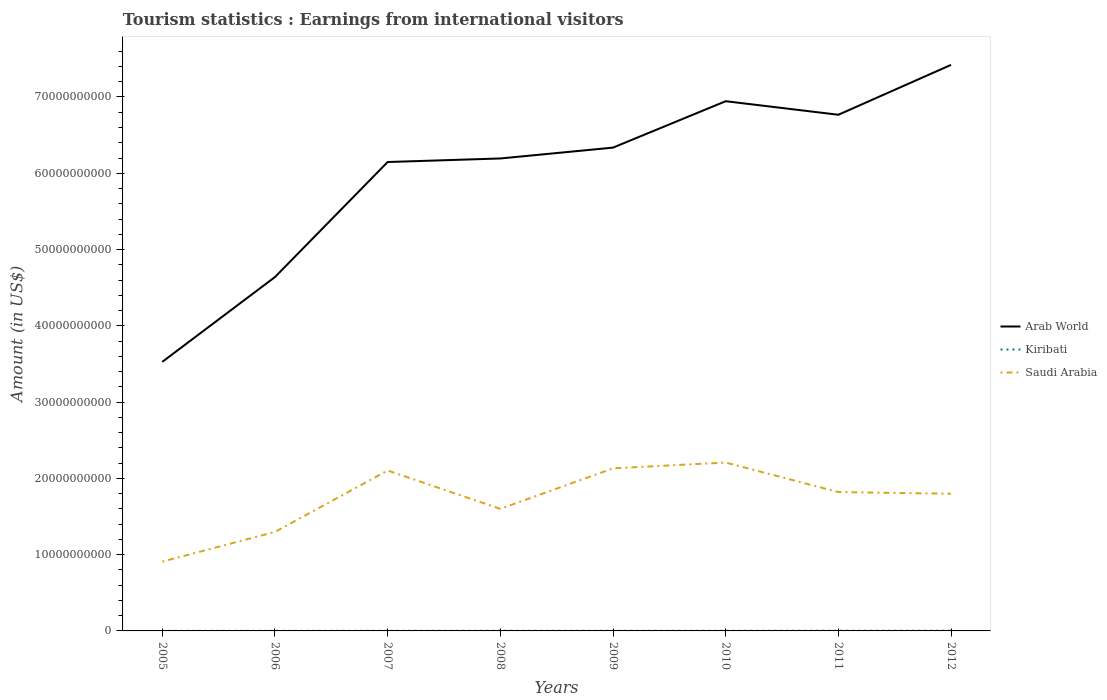Does the line corresponding to Kiribati intersect with the line corresponding to Saudi Arabia?
Provide a succinct answer. No. Across all years, what is the maximum earnings from international visitors in Kiribati?
Give a very brief answer. 9.30e+06. In which year was the earnings from international visitors in Saudi Arabia maximum?
Give a very brief answer. 2005. What is the total earnings from international visitors in Kiribati in the graph?
Make the answer very short. -9.00e+06. What is the difference between the highest and the second highest earnings from international visitors in Saudi Arabia?
Provide a succinct answer. 1.30e+1. How many lines are there?
Offer a very short reply. 3. Does the graph contain any zero values?
Your answer should be very brief. No. Does the graph contain grids?
Provide a short and direct response. No. Where does the legend appear in the graph?
Your answer should be compact. Center right. What is the title of the graph?
Ensure brevity in your answer.  Tourism statistics : Earnings from international visitors. Does "Middle East & North Africa (all income levels)" appear as one of the legend labels in the graph?
Provide a short and direct response. No. What is the label or title of the Y-axis?
Keep it short and to the point. Amount (in US$). What is the Amount (in US$) in Arab World in 2005?
Your response must be concise. 3.53e+1. What is the Amount (in US$) in Kiribati in 2005?
Provide a short and direct response. 9.30e+06. What is the Amount (in US$) in Saudi Arabia in 2005?
Keep it short and to the point. 9.09e+09. What is the Amount (in US$) of Arab World in 2006?
Your answer should be very brief. 4.64e+1. What is the Amount (in US$) in Kiribati in 2006?
Ensure brevity in your answer.  9.60e+06. What is the Amount (in US$) in Saudi Arabia in 2006?
Provide a succinct answer. 1.30e+1. What is the Amount (in US$) of Arab World in 2007?
Provide a short and direct response. 6.15e+1. What is the Amount (in US$) in Kiribati in 2007?
Your answer should be compact. 1.81e+07. What is the Amount (in US$) of Saudi Arabia in 2007?
Offer a terse response. 2.10e+1. What is the Amount (in US$) in Arab World in 2008?
Provide a succinct answer. 6.19e+1. What is the Amount (in US$) of Kiribati in 2008?
Your answer should be compact. 2.38e+07. What is the Amount (in US$) of Saudi Arabia in 2008?
Provide a short and direct response. 1.60e+1. What is the Amount (in US$) of Arab World in 2009?
Keep it short and to the point. 6.34e+1. What is the Amount (in US$) in Kiribati in 2009?
Your answer should be compact. 2.02e+07. What is the Amount (in US$) of Saudi Arabia in 2009?
Your response must be concise. 2.13e+1. What is the Amount (in US$) in Arab World in 2010?
Ensure brevity in your answer.  6.94e+1. What is the Amount (in US$) in Kiribati in 2010?
Offer a terse response. 2.26e+07. What is the Amount (in US$) in Saudi Arabia in 2010?
Ensure brevity in your answer.  2.21e+1. What is the Amount (in US$) in Arab World in 2011?
Ensure brevity in your answer.  6.77e+1. What is the Amount (in US$) in Kiribati in 2011?
Ensure brevity in your answer.  2.90e+07. What is the Amount (in US$) in Saudi Arabia in 2011?
Your answer should be compact. 1.82e+1. What is the Amount (in US$) of Arab World in 2012?
Provide a short and direct response. 7.42e+1. What is the Amount (in US$) in Kiribati in 2012?
Your answer should be very brief. 3.16e+07. What is the Amount (in US$) of Saudi Arabia in 2012?
Provide a succinct answer. 1.80e+1. Across all years, what is the maximum Amount (in US$) in Arab World?
Provide a short and direct response. 7.42e+1. Across all years, what is the maximum Amount (in US$) of Kiribati?
Give a very brief answer. 3.16e+07. Across all years, what is the maximum Amount (in US$) of Saudi Arabia?
Make the answer very short. 2.21e+1. Across all years, what is the minimum Amount (in US$) of Arab World?
Keep it short and to the point. 3.53e+1. Across all years, what is the minimum Amount (in US$) in Kiribati?
Provide a short and direct response. 9.30e+06. Across all years, what is the minimum Amount (in US$) of Saudi Arabia?
Give a very brief answer. 9.09e+09. What is the total Amount (in US$) of Arab World in the graph?
Provide a short and direct response. 4.80e+11. What is the total Amount (in US$) in Kiribati in the graph?
Make the answer very short. 1.64e+08. What is the total Amount (in US$) of Saudi Arabia in the graph?
Your response must be concise. 1.39e+11. What is the difference between the Amount (in US$) in Arab World in 2005 and that in 2006?
Offer a very short reply. -1.11e+1. What is the difference between the Amount (in US$) in Saudi Arabia in 2005 and that in 2006?
Your answer should be compact. -3.89e+09. What is the difference between the Amount (in US$) of Arab World in 2005 and that in 2007?
Your answer should be compact. -2.62e+1. What is the difference between the Amount (in US$) in Kiribati in 2005 and that in 2007?
Make the answer very short. -8.80e+06. What is the difference between the Amount (in US$) of Saudi Arabia in 2005 and that in 2007?
Your answer should be very brief. -1.19e+1. What is the difference between the Amount (in US$) of Arab World in 2005 and that in 2008?
Offer a very short reply. -2.67e+1. What is the difference between the Amount (in US$) of Kiribati in 2005 and that in 2008?
Keep it short and to the point. -1.45e+07. What is the difference between the Amount (in US$) in Saudi Arabia in 2005 and that in 2008?
Offer a very short reply. -6.92e+09. What is the difference between the Amount (in US$) in Arab World in 2005 and that in 2009?
Your answer should be compact. -2.81e+1. What is the difference between the Amount (in US$) in Kiribati in 2005 and that in 2009?
Offer a terse response. -1.09e+07. What is the difference between the Amount (in US$) of Saudi Arabia in 2005 and that in 2009?
Provide a succinct answer. -1.22e+1. What is the difference between the Amount (in US$) in Arab World in 2005 and that in 2010?
Give a very brief answer. -3.42e+1. What is the difference between the Amount (in US$) of Kiribati in 2005 and that in 2010?
Provide a succinct answer. -1.33e+07. What is the difference between the Amount (in US$) of Saudi Arabia in 2005 and that in 2010?
Your response must be concise. -1.30e+1. What is the difference between the Amount (in US$) in Arab World in 2005 and that in 2011?
Your answer should be compact. -3.24e+1. What is the difference between the Amount (in US$) in Kiribati in 2005 and that in 2011?
Keep it short and to the point. -1.97e+07. What is the difference between the Amount (in US$) of Saudi Arabia in 2005 and that in 2011?
Ensure brevity in your answer.  -9.12e+09. What is the difference between the Amount (in US$) in Arab World in 2005 and that in 2012?
Make the answer very short. -3.89e+1. What is the difference between the Amount (in US$) in Kiribati in 2005 and that in 2012?
Make the answer very short. -2.23e+07. What is the difference between the Amount (in US$) in Saudi Arabia in 2005 and that in 2012?
Provide a short and direct response. -8.90e+09. What is the difference between the Amount (in US$) of Arab World in 2006 and that in 2007?
Offer a terse response. -1.51e+1. What is the difference between the Amount (in US$) of Kiribati in 2006 and that in 2007?
Your answer should be very brief. -8.50e+06. What is the difference between the Amount (in US$) in Saudi Arabia in 2006 and that in 2007?
Make the answer very short. -8.05e+09. What is the difference between the Amount (in US$) of Arab World in 2006 and that in 2008?
Provide a succinct answer. -1.55e+1. What is the difference between the Amount (in US$) of Kiribati in 2006 and that in 2008?
Your answer should be very brief. -1.42e+07. What is the difference between the Amount (in US$) in Saudi Arabia in 2006 and that in 2008?
Ensure brevity in your answer.  -3.03e+09. What is the difference between the Amount (in US$) in Arab World in 2006 and that in 2009?
Keep it short and to the point. -1.70e+1. What is the difference between the Amount (in US$) of Kiribati in 2006 and that in 2009?
Give a very brief answer. -1.06e+07. What is the difference between the Amount (in US$) of Saudi Arabia in 2006 and that in 2009?
Offer a terse response. -8.33e+09. What is the difference between the Amount (in US$) in Arab World in 2006 and that in 2010?
Keep it short and to the point. -2.31e+1. What is the difference between the Amount (in US$) of Kiribati in 2006 and that in 2010?
Make the answer very short. -1.30e+07. What is the difference between the Amount (in US$) in Saudi Arabia in 2006 and that in 2010?
Provide a short and direct response. -9.10e+09. What is the difference between the Amount (in US$) in Arab World in 2006 and that in 2011?
Provide a succinct answer. -2.13e+1. What is the difference between the Amount (in US$) in Kiribati in 2006 and that in 2011?
Offer a terse response. -1.94e+07. What is the difference between the Amount (in US$) of Saudi Arabia in 2006 and that in 2011?
Give a very brief answer. -5.22e+09. What is the difference between the Amount (in US$) in Arab World in 2006 and that in 2012?
Your answer should be very brief. -2.78e+1. What is the difference between the Amount (in US$) of Kiribati in 2006 and that in 2012?
Offer a very short reply. -2.20e+07. What is the difference between the Amount (in US$) of Saudi Arabia in 2006 and that in 2012?
Provide a short and direct response. -5.01e+09. What is the difference between the Amount (in US$) of Arab World in 2007 and that in 2008?
Provide a succinct answer. -4.64e+08. What is the difference between the Amount (in US$) in Kiribati in 2007 and that in 2008?
Provide a succinct answer. -5.70e+06. What is the difference between the Amount (in US$) of Saudi Arabia in 2007 and that in 2008?
Keep it short and to the point. 5.03e+09. What is the difference between the Amount (in US$) in Arab World in 2007 and that in 2009?
Your response must be concise. -1.89e+09. What is the difference between the Amount (in US$) of Kiribati in 2007 and that in 2009?
Offer a very short reply. -2.10e+06. What is the difference between the Amount (in US$) in Saudi Arabia in 2007 and that in 2009?
Your answer should be compact. -2.81e+08. What is the difference between the Amount (in US$) of Arab World in 2007 and that in 2010?
Make the answer very short. -7.97e+09. What is the difference between the Amount (in US$) in Kiribati in 2007 and that in 2010?
Make the answer very short. -4.50e+06. What is the difference between the Amount (in US$) in Saudi Arabia in 2007 and that in 2010?
Make the answer very short. -1.04e+09. What is the difference between the Amount (in US$) of Arab World in 2007 and that in 2011?
Ensure brevity in your answer.  -6.20e+09. What is the difference between the Amount (in US$) of Kiribati in 2007 and that in 2011?
Provide a succinct answer. -1.09e+07. What is the difference between the Amount (in US$) of Saudi Arabia in 2007 and that in 2011?
Provide a succinct answer. 2.83e+09. What is the difference between the Amount (in US$) in Arab World in 2007 and that in 2012?
Ensure brevity in your answer.  -1.27e+1. What is the difference between the Amount (in US$) in Kiribati in 2007 and that in 2012?
Ensure brevity in your answer.  -1.35e+07. What is the difference between the Amount (in US$) of Saudi Arabia in 2007 and that in 2012?
Give a very brief answer. 3.04e+09. What is the difference between the Amount (in US$) of Arab World in 2008 and that in 2009?
Offer a terse response. -1.42e+09. What is the difference between the Amount (in US$) in Kiribati in 2008 and that in 2009?
Your answer should be very brief. 3.60e+06. What is the difference between the Amount (in US$) in Saudi Arabia in 2008 and that in 2009?
Make the answer very short. -5.31e+09. What is the difference between the Amount (in US$) in Arab World in 2008 and that in 2010?
Make the answer very short. -7.51e+09. What is the difference between the Amount (in US$) of Kiribati in 2008 and that in 2010?
Provide a succinct answer. 1.20e+06. What is the difference between the Amount (in US$) in Saudi Arabia in 2008 and that in 2010?
Offer a terse response. -6.07e+09. What is the difference between the Amount (in US$) of Arab World in 2008 and that in 2011?
Give a very brief answer. -5.73e+09. What is the difference between the Amount (in US$) of Kiribati in 2008 and that in 2011?
Your answer should be very brief. -5.20e+06. What is the difference between the Amount (in US$) in Saudi Arabia in 2008 and that in 2011?
Provide a succinct answer. -2.20e+09. What is the difference between the Amount (in US$) in Arab World in 2008 and that in 2012?
Provide a short and direct response. -1.23e+1. What is the difference between the Amount (in US$) of Kiribati in 2008 and that in 2012?
Keep it short and to the point. -7.80e+06. What is the difference between the Amount (in US$) in Saudi Arabia in 2008 and that in 2012?
Ensure brevity in your answer.  -1.98e+09. What is the difference between the Amount (in US$) in Arab World in 2009 and that in 2010?
Make the answer very short. -6.08e+09. What is the difference between the Amount (in US$) in Kiribati in 2009 and that in 2010?
Give a very brief answer. -2.40e+06. What is the difference between the Amount (in US$) in Saudi Arabia in 2009 and that in 2010?
Give a very brief answer. -7.64e+08. What is the difference between the Amount (in US$) in Arab World in 2009 and that in 2011?
Keep it short and to the point. -4.31e+09. What is the difference between the Amount (in US$) of Kiribati in 2009 and that in 2011?
Provide a succinct answer. -8.80e+06. What is the difference between the Amount (in US$) of Saudi Arabia in 2009 and that in 2011?
Provide a succinct answer. 3.11e+09. What is the difference between the Amount (in US$) in Arab World in 2009 and that in 2012?
Keep it short and to the point. -1.08e+1. What is the difference between the Amount (in US$) in Kiribati in 2009 and that in 2012?
Keep it short and to the point. -1.14e+07. What is the difference between the Amount (in US$) in Saudi Arabia in 2009 and that in 2012?
Your answer should be very brief. 3.33e+09. What is the difference between the Amount (in US$) in Arab World in 2010 and that in 2011?
Keep it short and to the point. 1.77e+09. What is the difference between the Amount (in US$) of Kiribati in 2010 and that in 2011?
Your answer should be compact. -6.40e+06. What is the difference between the Amount (in US$) in Saudi Arabia in 2010 and that in 2011?
Ensure brevity in your answer.  3.87e+09. What is the difference between the Amount (in US$) of Arab World in 2010 and that in 2012?
Your answer should be compact. -4.76e+09. What is the difference between the Amount (in US$) in Kiribati in 2010 and that in 2012?
Offer a very short reply. -9.00e+06. What is the difference between the Amount (in US$) in Saudi Arabia in 2010 and that in 2012?
Keep it short and to the point. 4.09e+09. What is the difference between the Amount (in US$) in Arab World in 2011 and that in 2012?
Your answer should be very brief. -6.54e+09. What is the difference between the Amount (in US$) in Kiribati in 2011 and that in 2012?
Provide a succinct answer. -2.60e+06. What is the difference between the Amount (in US$) of Saudi Arabia in 2011 and that in 2012?
Offer a terse response. 2.16e+08. What is the difference between the Amount (in US$) in Arab World in 2005 and the Amount (in US$) in Kiribati in 2006?
Keep it short and to the point. 3.53e+1. What is the difference between the Amount (in US$) in Arab World in 2005 and the Amount (in US$) in Saudi Arabia in 2006?
Provide a succinct answer. 2.23e+1. What is the difference between the Amount (in US$) in Kiribati in 2005 and the Amount (in US$) in Saudi Arabia in 2006?
Provide a succinct answer. -1.30e+1. What is the difference between the Amount (in US$) of Arab World in 2005 and the Amount (in US$) of Kiribati in 2007?
Provide a succinct answer. 3.53e+1. What is the difference between the Amount (in US$) of Arab World in 2005 and the Amount (in US$) of Saudi Arabia in 2007?
Ensure brevity in your answer.  1.42e+1. What is the difference between the Amount (in US$) in Kiribati in 2005 and the Amount (in US$) in Saudi Arabia in 2007?
Your response must be concise. -2.10e+1. What is the difference between the Amount (in US$) of Arab World in 2005 and the Amount (in US$) of Kiribati in 2008?
Give a very brief answer. 3.53e+1. What is the difference between the Amount (in US$) in Arab World in 2005 and the Amount (in US$) in Saudi Arabia in 2008?
Give a very brief answer. 1.93e+1. What is the difference between the Amount (in US$) of Kiribati in 2005 and the Amount (in US$) of Saudi Arabia in 2008?
Your answer should be very brief. -1.60e+1. What is the difference between the Amount (in US$) of Arab World in 2005 and the Amount (in US$) of Kiribati in 2009?
Keep it short and to the point. 3.53e+1. What is the difference between the Amount (in US$) in Arab World in 2005 and the Amount (in US$) in Saudi Arabia in 2009?
Give a very brief answer. 1.40e+1. What is the difference between the Amount (in US$) of Kiribati in 2005 and the Amount (in US$) of Saudi Arabia in 2009?
Your answer should be compact. -2.13e+1. What is the difference between the Amount (in US$) of Arab World in 2005 and the Amount (in US$) of Kiribati in 2010?
Make the answer very short. 3.53e+1. What is the difference between the Amount (in US$) of Arab World in 2005 and the Amount (in US$) of Saudi Arabia in 2010?
Make the answer very short. 1.32e+1. What is the difference between the Amount (in US$) of Kiribati in 2005 and the Amount (in US$) of Saudi Arabia in 2010?
Keep it short and to the point. -2.21e+1. What is the difference between the Amount (in US$) of Arab World in 2005 and the Amount (in US$) of Kiribati in 2011?
Provide a short and direct response. 3.52e+1. What is the difference between the Amount (in US$) of Arab World in 2005 and the Amount (in US$) of Saudi Arabia in 2011?
Ensure brevity in your answer.  1.71e+1. What is the difference between the Amount (in US$) in Kiribati in 2005 and the Amount (in US$) in Saudi Arabia in 2011?
Keep it short and to the point. -1.82e+1. What is the difference between the Amount (in US$) in Arab World in 2005 and the Amount (in US$) in Kiribati in 2012?
Provide a short and direct response. 3.52e+1. What is the difference between the Amount (in US$) in Arab World in 2005 and the Amount (in US$) in Saudi Arabia in 2012?
Ensure brevity in your answer.  1.73e+1. What is the difference between the Amount (in US$) of Kiribati in 2005 and the Amount (in US$) of Saudi Arabia in 2012?
Your answer should be compact. -1.80e+1. What is the difference between the Amount (in US$) of Arab World in 2006 and the Amount (in US$) of Kiribati in 2007?
Give a very brief answer. 4.64e+1. What is the difference between the Amount (in US$) in Arab World in 2006 and the Amount (in US$) in Saudi Arabia in 2007?
Make the answer very short. 2.54e+1. What is the difference between the Amount (in US$) of Kiribati in 2006 and the Amount (in US$) of Saudi Arabia in 2007?
Ensure brevity in your answer.  -2.10e+1. What is the difference between the Amount (in US$) in Arab World in 2006 and the Amount (in US$) in Kiribati in 2008?
Provide a short and direct response. 4.64e+1. What is the difference between the Amount (in US$) of Arab World in 2006 and the Amount (in US$) of Saudi Arabia in 2008?
Ensure brevity in your answer.  3.04e+1. What is the difference between the Amount (in US$) in Kiribati in 2006 and the Amount (in US$) in Saudi Arabia in 2008?
Your answer should be very brief. -1.60e+1. What is the difference between the Amount (in US$) of Arab World in 2006 and the Amount (in US$) of Kiribati in 2009?
Your response must be concise. 4.64e+1. What is the difference between the Amount (in US$) of Arab World in 2006 and the Amount (in US$) of Saudi Arabia in 2009?
Provide a succinct answer. 2.51e+1. What is the difference between the Amount (in US$) in Kiribati in 2006 and the Amount (in US$) in Saudi Arabia in 2009?
Provide a succinct answer. -2.13e+1. What is the difference between the Amount (in US$) of Arab World in 2006 and the Amount (in US$) of Kiribati in 2010?
Offer a terse response. 4.64e+1. What is the difference between the Amount (in US$) in Arab World in 2006 and the Amount (in US$) in Saudi Arabia in 2010?
Offer a terse response. 2.43e+1. What is the difference between the Amount (in US$) of Kiribati in 2006 and the Amount (in US$) of Saudi Arabia in 2010?
Keep it short and to the point. -2.21e+1. What is the difference between the Amount (in US$) of Arab World in 2006 and the Amount (in US$) of Kiribati in 2011?
Keep it short and to the point. 4.64e+1. What is the difference between the Amount (in US$) in Arab World in 2006 and the Amount (in US$) in Saudi Arabia in 2011?
Offer a very short reply. 2.82e+1. What is the difference between the Amount (in US$) of Kiribati in 2006 and the Amount (in US$) of Saudi Arabia in 2011?
Give a very brief answer. -1.82e+1. What is the difference between the Amount (in US$) of Arab World in 2006 and the Amount (in US$) of Kiribati in 2012?
Your answer should be compact. 4.64e+1. What is the difference between the Amount (in US$) of Arab World in 2006 and the Amount (in US$) of Saudi Arabia in 2012?
Ensure brevity in your answer.  2.84e+1. What is the difference between the Amount (in US$) in Kiribati in 2006 and the Amount (in US$) in Saudi Arabia in 2012?
Ensure brevity in your answer.  -1.80e+1. What is the difference between the Amount (in US$) of Arab World in 2007 and the Amount (in US$) of Kiribati in 2008?
Make the answer very short. 6.15e+1. What is the difference between the Amount (in US$) of Arab World in 2007 and the Amount (in US$) of Saudi Arabia in 2008?
Offer a very short reply. 4.55e+1. What is the difference between the Amount (in US$) in Kiribati in 2007 and the Amount (in US$) in Saudi Arabia in 2008?
Offer a very short reply. -1.60e+1. What is the difference between the Amount (in US$) in Arab World in 2007 and the Amount (in US$) in Kiribati in 2009?
Offer a very short reply. 6.15e+1. What is the difference between the Amount (in US$) of Arab World in 2007 and the Amount (in US$) of Saudi Arabia in 2009?
Make the answer very short. 4.02e+1. What is the difference between the Amount (in US$) of Kiribati in 2007 and the Amount (in US$) of Saudi Arabia in 2009?
Offer a very short reply. -2.13e+1. What is the difference between the Amount (in US$) of Arab World in 2007 and the Amount (in US$) of Kiribati in 2010?
Ensure brevity in your answer.  6.15e+1. What is the difference between the Amount (in US$) in Arab World in 2007 and the Amount (in US$) in Saudi Arabia in 2010?
Your answer should be very brief. 3.94e+1. What is the difference between the Amount (in US$) of Kiribati in 2007 and the Amount (in US$) of Saudi Arabia in 2010?
Your answer should be compact. -2.21e+1. What is the difference between the Amount (in US$) of Arab World in 2007 and the Amount (in US$) of Kiribati in 2011?
Ensure brevity in your answer.  6.14e+1. What is the difference between the Amount (in US$) of Arab World in 2007 and the Amount (in US$) of Saudi Arabia in 2011?
Give a very brief answer. 4.33e+1. What is the difference between the Amount (in US$) in Kiribati in 2007 and the Amount (in US$) in Saudi Arabia in 2011?
Give a very brief answer. -1.82e+1. What is the difference between the Amount (in US$) in Arab World in 2007 and the Amount (in US$) in Kiribati in 2012?
Keep it short and to the point. 6.14e+1. What is the difference between the Amount (in US$) in Arab World in 2007 and the Amount (in US$) in Saudi Arabia in 2012?
Your answer should be compact. 4.35e+1. What is the difference between the Amount (in US$) in Kiribati in 2007 and the Amount (in US$) in Saudi Arabia in 2012?
Provide a succinct answer. -1.80e+1. What is the difference between the Amount (in US$) in Arab World in 2008 and the Amount (in US$) in Kiribati in 2009?
Your answer should be very brief. 6.19e+1. What is the difference between the Amount (in US$) of Arab World in 2008 and the Amount (in US$) of Saudi Arabia in 2009?
Keep it short and to the point. 4.06e+1. What is the difference between the Amount (in US$) in Kiribati in 2008 and the Amount (in US$) in Saudi Arabia in 2009?
Offer a terse response. -2.13e+1. What is the difference between the Amount (in US$) of Arab World in 2008 and the Amount (in US$) of Kiribati in 2010?
Make the answer very short. 6.19e+1. What is the difference between the Amount (in US$) in Arab World in 2008 and the Amount (in US$) in Saudi Arabia in 2010?
Your answer should be very brief. 3.99e+1. What is the difference between the Amount (in US$) of Kiribati in 2008 and the Amount (in US$) of Saudi Arabia in 2010?
Your response must be concise. -2.21e+1. What is the difference between the Amount (in US$) in Arab World in 2008 and the Amount (in US$) in Kiribati in 2011?
Ensure brevity in your answer.  6.19e+1. What is the difference between the Amount (in US$) in Arab World in 2008 and the Amount (in US$) in Saudi Arabia in 2011?
Give a very brief answer. 4.37e+1. What is the difference between the Amount (in US$) of Kiribati in 2008 and the Amount (in US$) of Saudi Arabia in 2011?
Your response must be concise. -1.82e+1. What is the difference between the Amount (in US$) of Arab World in 2008 and the Amount (in US$) of Kiribati in 2012?
Make the answer very short. 6.19e+1. What is the difference between the Amount (in US$) of Arab World in 2008 and the Amount (in US$) of Saudi Arabia in 2012?
Ensure brevity in your answer.  4.40e+1. What is the difference between the Amount (in US$) in Kiribati in 2008 and the Amount (in US$) in Saudi Arabia in 2012?
Your answer should be compact. -1.80e+1. What is the difference between the Amount (in US$) of Arab World in 2009 and the Amount (in US$) of Kiribati in 2010?
Make the answer very short. 6.33e+1. What is the difference between the Amount (in US$) of Arab World in 2009 and the Amount (in US$) of Saudi Arabia in 2010?
Make the answer very short. 4.13e+1. What is the difference between the Amount (in US$) of Kiribati in 2009 and the Amount (in US$) of Saudi Arabia in 2010?
Provide a short and direct response. -2.21e+1. What is the difference between the Amount (in US$) in Arab World in 2009 and the Amount (in US$) in Kiribati in 2011?
Your answer should be very brief. 6.33e+1. What is the difference between the Amount (in US$) in Arab World in 2009 and the Amount (in US$) in Saudi Arabia in 2011?
Ensure brevity in your answer.  4.52e+1. What is the difference between the Amount (in US$) of Kiribati in 2009 and the Amount (in US$) of Saudi Arabia in 2011?
Your answer should be compact. -1.82e+1. What is the difference between the Amount (in US$) of Arab World in 2009 and the Amount (in US$) of Kiribati in 2012?
Offer a very short reply. 6.33e+1. What is the difference between the Amount (in US$) of Arab World in 2009 and the Amount (in US$) of Saudi Arabia in 2012?
Ensure brevity in your answer.  4.54e+1. What is the difference between the Amount (in US$) in Kiribati in 2009 and the Amount (in US$) in Saudi Arabia in 2012?
Give a very brief answer. -1.80e+1. What is the difference between the Amount (in US$) of Arab World in 2010 and the Amount (in US$) of Kiribati in 2011?
Ensure brevity in your answer.  6.94e+1. What is the difference between the Amount (in US$) of Arab World in 2010 and the Amount (in US$) of Saudi Arabia in 2011?
Your response must be concise. 5.12e+1. What is the difference between the Amount (in US$) of Kiribati in 2010 and the Amount (in US$) of Saudi Arabia in 2011?
Your answer should be very brief. -1.82e+1. What is the difference between the Amount (in US$) of Arab World in 2010 and the Amount (in US$) of Kiribati in 2012?
Your answer should be very brief. 6.94e+1. What is the difference between the Amount (in US$) of Arab World in 2010 and the Amount (in US$) of Saudi Arabia in 2012?
Provide a short and direct response. 5.15e+1. What is the difference between the Amount (in US$) of Kiribati in 2010 and the Amount (in US$) of Saudi Arabia in 2012?
Your answer should be compact. -1.80e+1. What is the difference between the Amount (in US$) of Arab World in 2011 and the Amount (in US$) of Kiribati in 2012?
Keep it short and to the point. 6.76e+1. What is the difference between the Amount (in US$) in Arab World in 2011 and the Amount (in US$) in Saudi Arabia in 2012?
Your response must be concise. 4.97e+1. What is the difference between the Amount (in US$) of Kiribati in 2011 and the Amount (in US$) of Saudi Arabia in 2012?
Ensure brevity in your answer.  -1.80e+1. What is the average Amount (in US$) in Arab World per year?
Your response must be concise. 6.00e+1. What is the average Amount (in US$) of Kiribati per year?
Your answer should be compact. 2.05e+07. What is the average Amount (in US$) in Saudi Arabia per year?
Offer a very short reply. 1.73e+1. In the year 2005, what is the difference between the Amount (in US$) in Arab World and Amount (in US$) in Kiribati?
Give a very brief answer. 3.53e+1. In the year 2005, what is the difference between the Amount (in US$) of Arab World and Amount (in US$) of Saudi Arabia?
Ensure brevity in your answer.  2.62e+1. In the year 2005, what is the difference between the Amount (in US$) of Kiribati and Amount (in US$) of Saudi Arabia?
Provide a succinct answer. -9.08e+09. In the year 2006, what is the difference between the Amount (in US$) in Arab World and Amount (in US$) in Kiribati?
Provide a short and direct response. 4.64e+1. In the year 2006, what is the difference between the Amount (in US$) in Arab World and Amount (in US$) in Saudi Arabia?
Make the answer very short. 3.34e+1. In the year 2006, what is the difference between the Amount (in US$) of Kiribati and Amount (in US$) of Saudi Arabia?
Give a very brief answer. -1.30e+1. In the year 2007, what is the difference between the Amount (in US$) of Arab World and Amount (in US$) of Kiribati?
Make the answer very short. 6.15e+1. In the year 2007, what is the difference between the Amount (in US$) in Arab World and Amount (in US$) in Saudi Arabia?
Ensure brevity in your answer.  4.04e+1. In the year 2007, what is the difference between the Amount (in US$) of Kiribati and Amount (in US$) of Saudi Arabia?
Keep it short and to the point. -2.10e+1. In the year 2008, what is the difference between the Amount (in US$) of Arab World and Amount (in US$) of Kiribati?
Keep it short and to the point. 6.19e+1. In the year 2008, what is the difference between the Amount (in US$) of Arab World and Amount (in US$) of Saudi Arabia?
Give a very brief answer. 4.59e+1. In the year 2008, what is the difference between the Amount (in US$) of Kiribati and Amount (in US$) of Saudi Arabia?
Offer a very short reply. -1.60e+1. In the year 2009, what is the difference between the Amount (in US$) of Arab World and Amount (in US$) of Kiribati?
Offer a very short reply. 6.33e+1. In the year 2009, what is the difference between the Amount (in US$) of Arab World and Amount (in US$) of Saudi Arabia?
Ensure brevity in your answer.  4.21e+1. In the year 2009, what is the difference between the Amount (in US$) in Kiribati and Amount (in US$) in Saudi Arabia?
Your answer should be compact. -2.13e+1. In the year 2010, what is the difference between the Amount (in US$) in Arab World and Amount (in US$) in Kiribati?
Provide a succinct answer. 6.94e+1. In the year 2010, what is the difference between the Amount (in US$) of Arab World and Amount (in US$) of Saudi Arabia?
Keep it short and to the point. 4.74e+1. In the year 2010, what is the difference between the Amount (in US$) in Kiribati and Amount (in US$) in Saudi Arabia?
Keep it short and to the point. -2.21e+1. In the year 2011, what is the difference between the Amount (in US$) in Arab World and Amount (in US$) in Kiribati?
Keep it short and to the point. 6.76e+1. In the year 2011, what is the difference between the Amount (in US$) of Arab World and Amount (in US$) of Saudi Arabia?
Keep it short and to the point. 4.95e+1. In the year 2011, what is the difference between the Amount (in US$) of Kiribati and Amount (in US$) of Saudi Arabia?
Your answer should be compact. -1.82e+1. In the year 2012, what is the difference between the Amount (in US$) of Arab World and Amount (in US$) of Kiribati?
Keep it short and to the point. 7.42e+1. In the year 2012, what is the difference between the Amount (in US$) in Arab World and Amount (in US$) in Saudi Arabia?
Your answer should be compact. 5.62e+1. In the year 2012, what is the difference between the Amount (in US$) in Kiribati and Amount (in US$) in Saudi Arabia?
Keep it short and to the point. -1.80e+1. What is the ratio of the Amount (in US$) of Arab World in 2005 to that in 2006?
Give a very brief answer. 0.76. What is the ratio of the Amount (in US$) in Kiribati in 2005 to that in 2006?
Your answer should be very brief. 0.97. What is the ratio of the Amount (in US$) of Saudi Arabia in 2005 to that in 2006?
Ensure brevity in your answer.  0.7. What is the ratio of the Amount (in US$) of Arab World in 2005 to that in 2007?
Keep it short and to the point. 0.57. What is the ratio of the Amount (in US$) of Kiribati in 2005 to that in 2007?
Provide a short and direct response. 0.51. What is the ratio of the Amount (in US$) of Saudi Arabia in 2005 to that in 2007?
Your answer should be very brief. 0.43. What is the ratio of the Amount (in US$) of Arab World in 2005 to that in 2008?
Provide a short and direct response. 0.57. What is the ratio of the Amount (in US$) in Kiribati in 2005 to that in 2008?
Give a very brief answer. 0.39. What is the ratio of the Amount (in US$) of Saudi Arabia in 2005 to that in 2008?
Your response must be concise. 0.57. What is the ratio of the Amount (in US$) of Arab World in 2005 to that in 2009?
Your answer should be compact. 0.56. What is the ratio of the Amount (in US$) of Kiribati in 2005 to that in 2009?
Ensure brevity in your answer.  0.46. What is the ratio of the Amount (in US$) in Saudi Arabia in 2005 to that in 2009?
Your answer should be compact. 0.43. What is the ratio of the Amount (in US$) in Arab World in 2005 to that in 2010?
Make the answer very short. 0.51. What is the ratio of the Amount (in US$) in Kiribati in 2005 to that in 2010?
Offer a terse response. 0.41. What is the ratio of the Amount (in US$) in Saudi Arabia in 2005 to that in 2010?
Your answer should be very brief. 0.41. What is the ratio of the Amount (in US$) of Arab World in 2005 to that in 2011?
Offer a very short reply. 0.52. What is the ratio of the Amount (in US$) in Kiribati in 2005 to that in 2011?
Your answer should be compact. 0.32. What is the ratio of the Amount (in US$) of Saudi Arabia in 2005 to that in 2011?
Offer a very short reply. 0.5. What is the ratio of the Amount (in US$) in Arab World in 2005 to that in 2012?
Your answer should be very brief. 0.48. What is the ratio of the Amount (in US$) of Kiribati in 2005 to that in 2012?
Provide a short and direct response. 0.29. What is the ratio of the Amount (in US$) of Saudi Arabia in 2005 to that in 2012?
Ensure brevity in your answer.  0.51. What is the ratio of the Amount (in US$) in Arab World in 2006 to that in 2007?
Offer a very short reply. 0.75. What is the ratio of the Amount (in US$) of Kiribati in 2006 to that in 2007?
Offer a terse response. 0.53. What is the ratio of the Amount (in US$) of Saudi Arabia in 2006 to that in 2007?
Offer a very short reply. 0.62. What is the ratio of the Amount (in US$) of Arab World in 2006 to that in 2008?
Keep it short and to the point. 0.75. What is the ratio of the Amount (in US$) of Kiribati in 2006 to that in 2008?
Keep it short and to the point. 0.4. What is the ratio of the Amount (in US$) of Saudi Arabia in 2006 to that in 2008?
Provide a succinct answer. 0.81. What is the ratio of the Amount (in US$) of Arab World in 2006 to that in 2009?
Provide a short and direct response. 0.73. What is the ratio of the Amount (in US$) of Kiribati in 2006 to that in 2009?
Make the answer very short. 0.48. What is the ratio of the Amount (in US$) of Saudi Arabia in 2006 to that in 2009?
Give a very brief answer. 0.61. What is the ratio of the Amount (in US$) of Arab World in 2006 to that in 2010?
Your answer should be compact. 0.67. What is the ratio of the Amount (in US$) of Kiribati in 2006 to that in 2010?
Give a very brief answer. 0.42. What is the ratio of the Amount (in US$) in Saudi Arabia in 2006 to that in 2010?
Ensure brevity in your answer.  0.59. What is the ratio of the Amount (in US$) in Arab World in 2006 to that in 2011?
Offer a terse response. 0.69. What is the ratio of the Amount (in US$) of Kiribati in 2006 to that in 2011?
Your answer should be compact. 0.33. What is the ratio of the Amount (in US$) of Saudi Arabia in 2006 to that in 2011?
Your response must be concise. 0.71. What is the ratio of the Amount (in US$) in Arab World in 2006 to that in 2012?
Offer a very short reply. 0.63. What is the ratio of the Amount (in US$) in Kiribati in 2006 to that in 2012?
Provide a short and direct response. 0.3. What is the ratio of the Amount (in US$) of Saudi Arabia in 2006 to that in 2012?
Offer a very short reply. 0.72. What is the ratio of the Amount (in US$) of Kiribati in 2007 to that in 2008?
Your response must be concise. 0.76. What is the ratio of the Amount (in US$) of Saudi Arabia in 2007 to that in 2008?
Provide a succinct answer. 1.31. What is the ratio of the Amount (in US$) in Arab World in 2007 to that in 2009?
Your answer should be very brief. 0.97. What is the ratio of the Amount (in US$) in Kiribati in 2007 to that in 2009?
Make the answer very short. 0.9. What is the ratio of the Amount (in US$) in Saudi Arabia in 2007 to that in 2009?
Make the answer very short. 0.99. What is the ratio of the Amount (in US$) of Arab World in 2007 to that in 2010?
Ensure brevity in your answer.  0.89. What is the ratio of the Amount (in US$) of Kiribati in 2007 to that in 2010?
Your response must be concise. 0.8. What is the ratio of the Amount (in US$) of Saudi Arabia in 2007 to that in 2010?
Offer a very short reply. 0.95. What is the ratio of the Amount (in US$) in Arab World in 2007 to that in 2011?
Make the answer very short. 0.91. What is the ratio of the Amount (in US$) of Kiribati in 2007 to that in 2011?
Your answer should be very brief. 0.62. What is the ratio of the Amount (in US$) of Saudi Arabia in 2007 to that in 2011?
Offer a very short reply. 1.16. What is the ratio of the Amount (in US$) of Arab World in 2007 to that in 2012?
Provide a succinct answer. 0.83. What is the ratio of the Amount (in US$) in Kiribati in 2007 to that in 2012?
Provide a succinct answer. 0.57. What is the ratio of the Amount (in US$) in Saudi Arabia in 2007 to that in 2012?
Offer a very short reply. 1.17. What is the ratio of the Amount (in US$) in Arab World in 2008 to that in 2009?
Offer a terse response. 0.98. What is the ratio of the Amount (in US$) of Kiribati in 2008 to that in 2009?
Keep it short and to the point. 1.18. What is the ratio of the Amount (in US$) in Saudi Arabia in 2008 to that in 2009?
Keep it short and to the point. 0.75. What is the ratio of the Amount (in US$) of Arab World in 2008 to that in 2010?
Provide a short and direct response. 0.89. What is the ratio of the Amount (in US$) of Kiribati in 2008 to that in 2010?
Keep it short and to the point. 1.05. What is the ratio of the Amount (in US$) in Saudi Arabia in 2008 to that in 2010?
Your answer should be very brief. 0.72. What is the ratio of the Amount (in US$) in Arab World in 2008 to that in 2011?
Your answer should be very brief. 0.92. What is the ratio of the Amount (in US$) of Kiribati in 2008 to that in 2011?
Provide a succinct answer. 0.82. What is the ratio of the Amount (in US$) of Saudi Arabia in 2008 to that in 2011?
Your answer should be compact. 0.88. What is the ratio of the Amount (in US$) in Arab World in 2008 to that in 2012?
Ensure brevity in your answer.  0.83. What is the ratio of the Amount (in US$) of Kiribati in 2008 to that in 2012?
Ensure brevity in your answer.  0.75. What is the ratio of the Amount (in US$) of Saudi Arabia in 2008 to that in 2012?
Your answer should be compact. 0.89. What is the ratio of the Amount (in US$) of Arab World in 2009 to that in 2010?
Offer a terse response. 0.91. What is the ratio of the Amount (in US$) of Kiribati in 2009 to that in 2010?
Ensure brevity in your answer.  0.89. What is the ratio of the Amount (in US$) of Saudi Arabia in 2009 to that in 2010?
Offer a terse response. 0.97. What is the ratio of the Amount (in US$) of Arab World in 2009 to that in 2011?
Your answer should be compact. 0.94. What is the ratio of the Amount (in US$) in Kiribati in 2009 to that in 2011?
Your answer should be very brief. 0.7. What is the ratio of the Amount (in US$) in Saudi Arabia in 2009 to that in 2011?
Provide a short and direct response. 1.17. What is the ratio of the Amount (in US$) of Arab World in 2009 to that in 2012?
Provide a succinct answer. 0.85. What is the ratio of the Amount (in US$) in Kiribati in 2009 to that in 2012?
Your answer should be very brief. 0.64. What is the ratio of the Amount (in US$) of Saudi Arabia in 2009 to that in 2012?
Ensure brevity in your answer.  1.18. What is the ratio of the Amount (in US$) in Arab World in 2010 to that in 2011?
Provide a short and direct response. 1.03. What is the ratio of the Amount (in US$) of Kiribati in 2010 to that in 2011?
Keep it short and to the point. 0.78. What is the ratio of the Amount (in US$) of Saudi Arabia in 2010 to that in 2011?
Ensure brevity in your answer.  1.21. What is the ratio of the Amount (in US$) in Arab World in 2010 to that in 2012?
Give a very brief answer. 0.94. What is the ratio of the Amount (in US$) of Kiribati in 2010 to that in 2012?
Ensure brevity in your answer.  0.72. What is the ratio of the Amount (in US$) of Saudi Arabia in 2010 to that in 2012?
Provide a succinct answer. 1.23. What is the ratio of the Amount (in US$) of Arab World in 2011 to that in 2012?
Offer a terse response. 0.91. What is the ratio of the Amount (in US$) of Kiribati in 2011 to that in 2012?
Your answer should be very brief. 0.92. What is the ratio of the Amount (in US$) in Saudi Arabia in 2011 to that in 2012?
Your answer should be compact. 1.01. What is the difference between the highest and the second highest Amount (in US$) of Arab World?
Offer a very short reply. 4.76e+09. What is the difference between the highest and the second highest Amount (in US$) in Kiribati?
Your response must be concise. 2.60e+06. What is the difference between the highest and the second highest Amount (in US$) of Saudi Arabia?
Keep it short and to the point. 7.64e+08. What is the difference between the highest and the lowest Amount (in US$) in Arab World?
Give a very brief answer. 3.89e+1. What is the difference between the highest and the lowest Amount (in US$) in Kiribati?
Provide a succinct answer. 2.23e+07. What is the difference between the highest and the lowest Amount (in US$) in Saudi Arabia?
Offer a very short reply. 1.30e+1. 